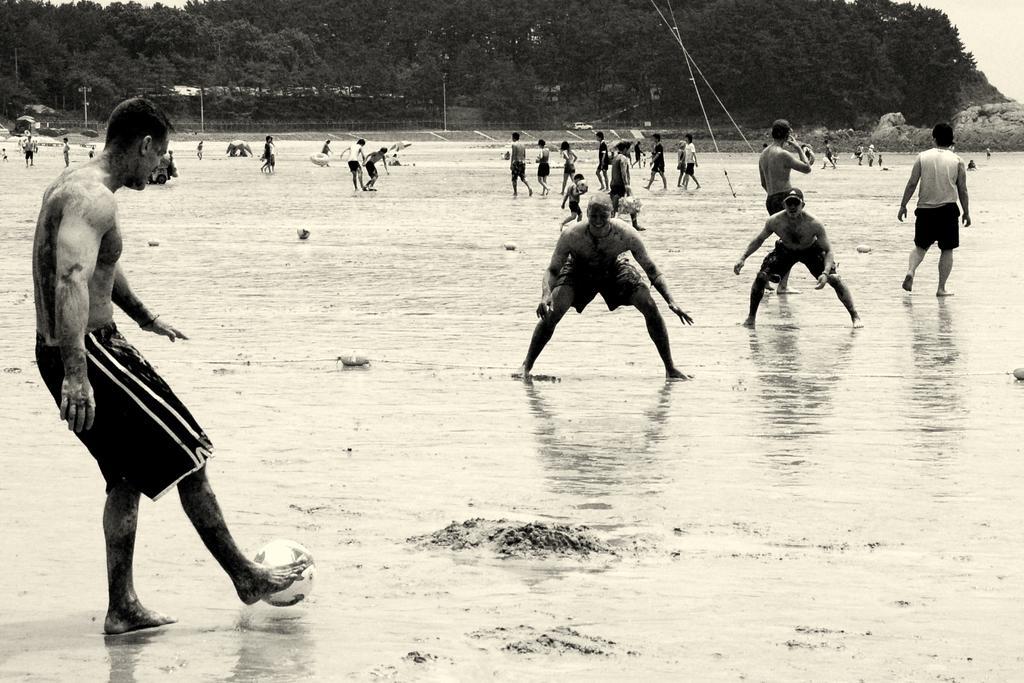In one or two sentences, can you explain what this image depicts? In this image, There are some people playing the football which is in white color, There is a water on the ground, In the background there are some green color trees. 